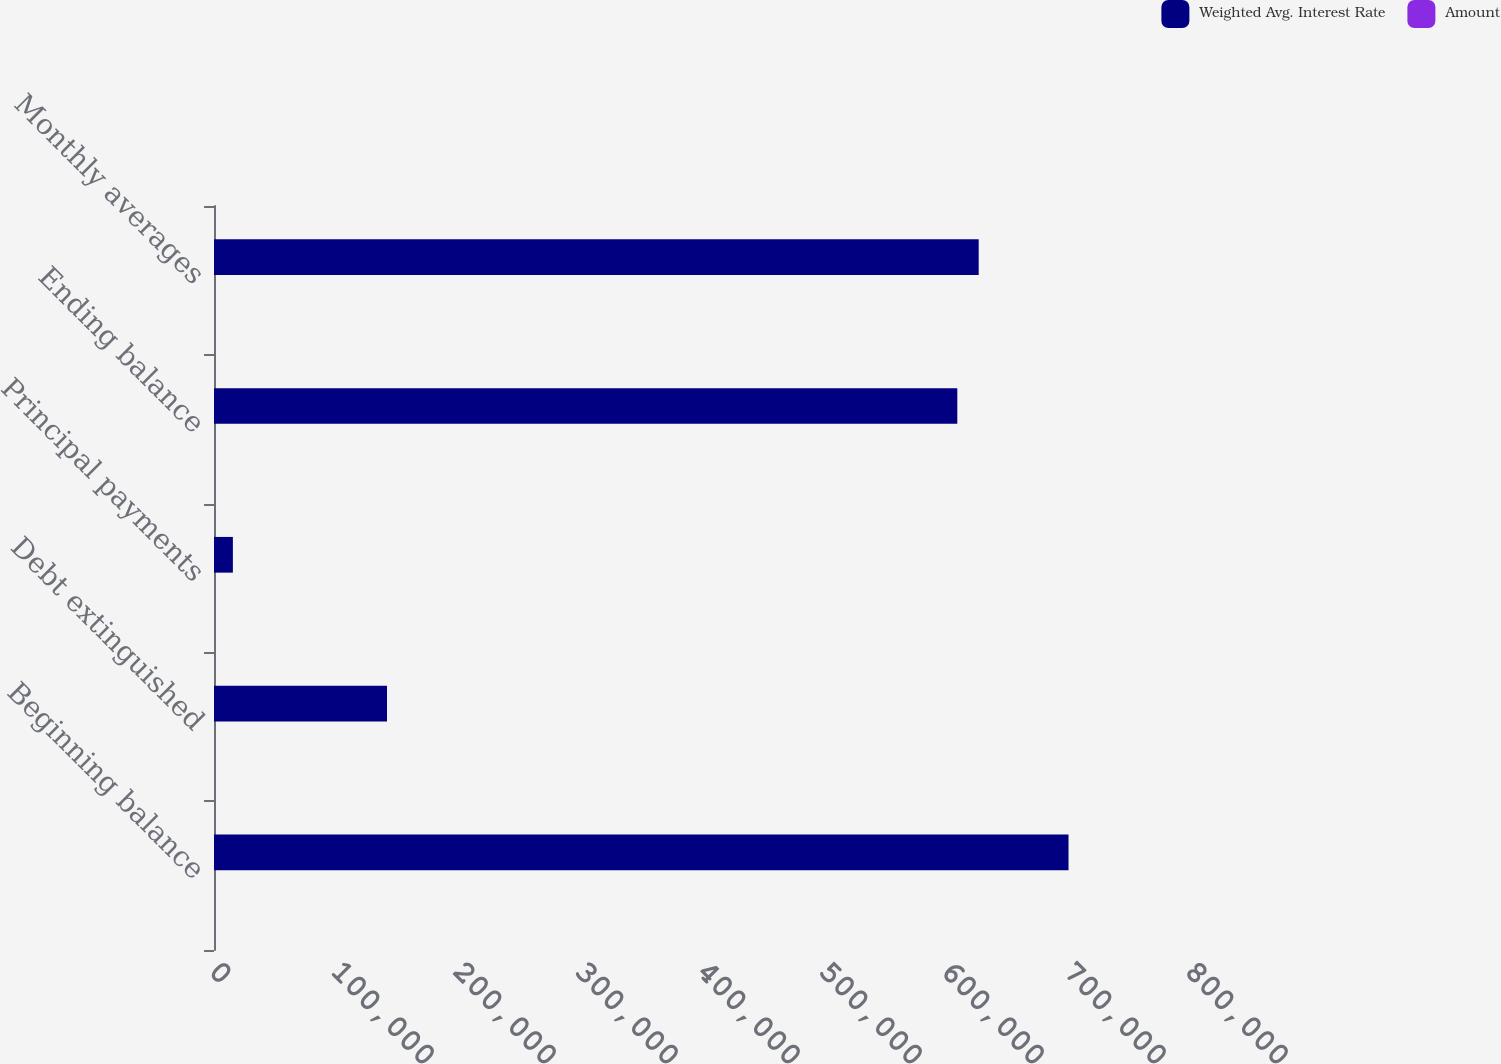<chart> <loc_0><loc_0><loc_500><loc_500><stacked_bar_chart><ecel><fcel>Beginning balance<fcel>Debt extinguished<fcel>Principal payments<fcel>Ending balance<fcel>Monthly averages<nl><fcel>Weighted Avg. Interest Rate<fcel>700427<fcel>141796<fcel>15476<fcel>609268<fcel>626797<nl><fcel>Amount<fcel>6<fcel>5.57<fcel>5.8<fcel>5.84<fcel>5.93<nl></chart> 